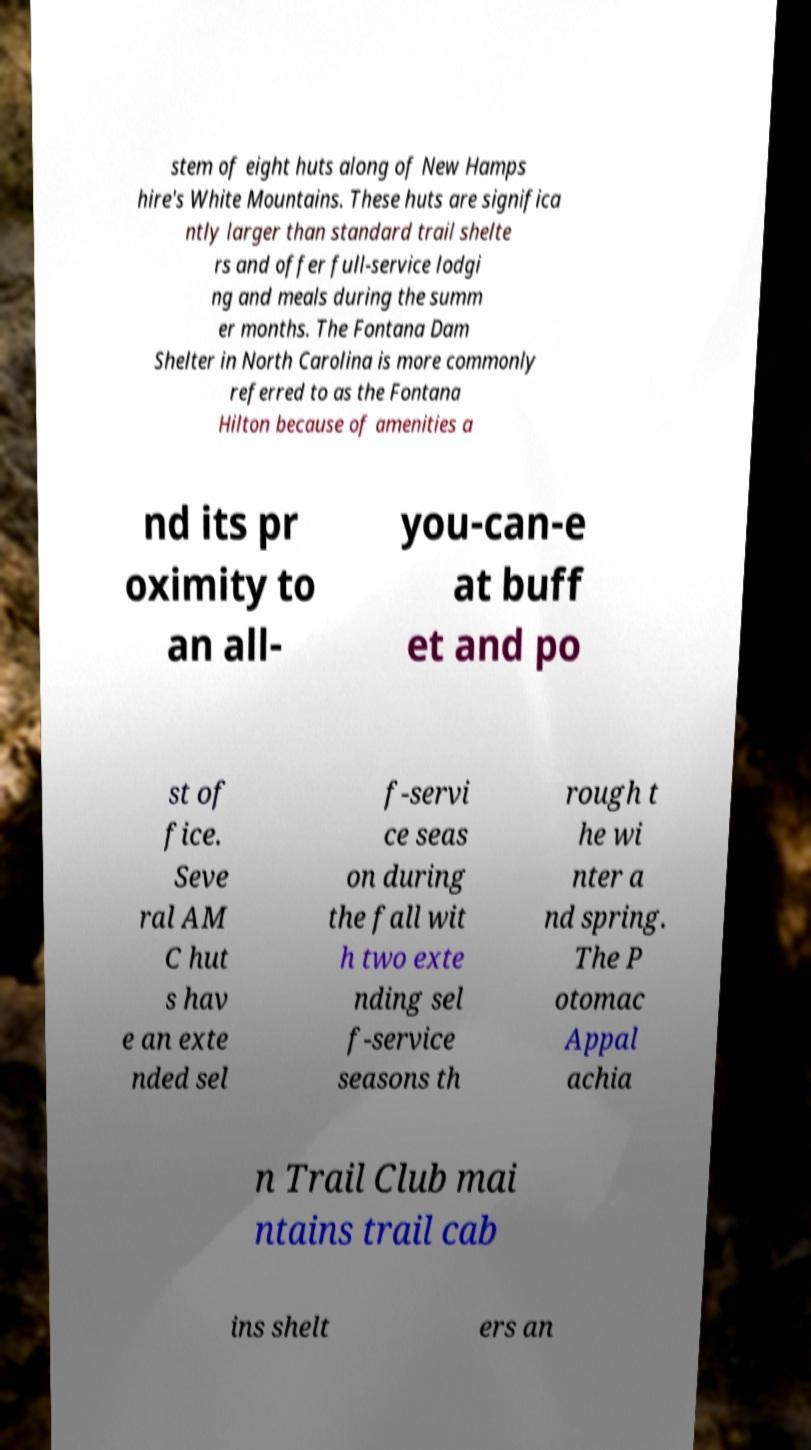What messages or text are displayed in this image? I need them in a readable, typed format. stem of eight huts along of New Hamps hire's White Mountains. These huts are significa ntly larger than standard trail shelte rs and offer full-service lodgi ng and meals during the summ er months. The Fontana Dam Shelter in North Carolina is more commonly referred to as the Fontana Hilton because of amenities a nd its pr oximity to an all- you-can-e at buff et and po st of fice. Seve ral AM C hut s hav e an exte nded sel f-servi ce seas on during the fall wit h two exte nding sel f-service seasons th rough t he wi nter a nd spring. The P otomac Appal achia n Trail Club mai ntains trail cab ins shelt ers an 